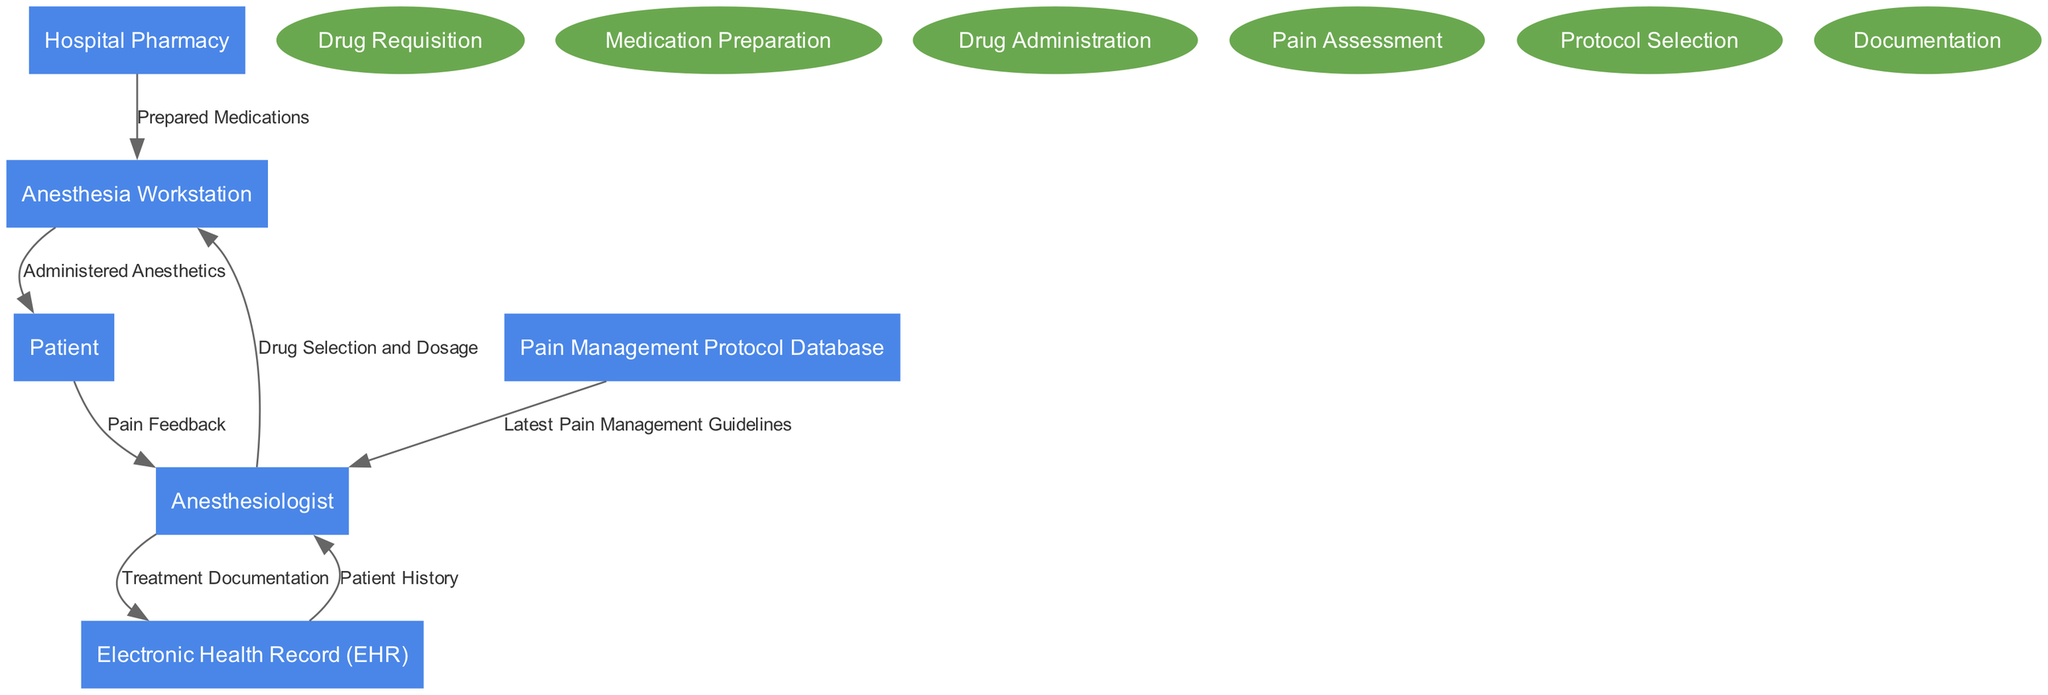What are the entities in the diagram? The entities in the diagram are the distinct components that interact within the anesthetic drug administration process. They can be identified as separate nodes in the diagram. In this case, the entities are: Hospital Pharmacy, Anesthesia Workstation, Patient, Electronic Health Record (EHR), Anesthesiologist, and Pain Management Protocol Database.
Answer: Hospital Pharmacy, Anesthesia Workstation, Patient, Electronic Health Record (EHR), Anesthesiologist, Pain Management Protocol Database How many processes are represented in the diagram? The processes are the actions or series of tasks carried out in the anesthetic process, represented as elliptical nodes in the diagram. There are six listed processes: Drug Requisition, Medication Preparation, Drug Administration, Pain Assessment, Protocol Selection, and Documentation. By counting these, we can determine there are six processes in total.
Answer: 6 What type of data flow occurs between the Hospital Pharmacy and the Anesthesia Workstation? The data flow between the Hospital Pharmacy and the Anesthesia Workstation is labeled "Prepared Medications." This indicates the transfer of ready-to-use anesthetic medications from the pharmacy to the workstation, which is a critical step in the administration process.
Answer: Prepared Medications Which two nodes are connected by the flow labeled "Administered Anesthetics"? The flow labeled "Administered Anesthetics" connects the Anesthesia Workstation to the Patient. This data flow signifies that the medications prepared at the workstation are actually given to the patient, marking a key point in the process where treatment is delivered.
Answer: Anesthesia Workstation and Patient What role does the Anesthesiologist play regarding the Pain Management Protocol Database? The Anesthesiologist interacts with the Pain Management Protocol Database by receiving the "Latest Pain Management Guidelines." This entails that the anesthesiologist uses this database to assist in deciding best practices and treatment options during the anesthetic procedure, providing a foundation for effective pain management.
Answer: Latest Pain Management Guidelines What information does the Patient provide back to the Anesthesiologist? The Patient provides "Pain Feedback" to the Anesthesiologist. This feedback is crucial for adjusting pain management strategies and ensuring that the patient is comfortable throughout the procedure. It allows the anesthesiologist to assess the effectiveness of the administered anesthetics.
Answer: Pain Feedback What happens after the Anesthesiologist documents the treatment in the EHR? The action of documenting treatment in the Electronic Health Record (EHR) doesn't explicitly show a subsequent flow in the diagram. However, it implies that the patient's records are updated with the information regarding treatment, which is vital for future reference and continuity of care. It is an important endpoint in this process flow.
Answer: Documentation in EHR How many data flows are depicted in the diagram? A data flow represents the movement of information or materials between nodes in the diagram. By counting each connection_with its respective labels, we find there are a total of seven data flows illustrated in the diagram.
Answer: 7 What processes are facilitated by the Anesthesiologist? The processes facilitated by the Anesthesiologist are Drug Selection and Dosage, Pain Assessment, and Treatment Documentation. These tasks involve making clinical decisions about drug administration and monitoring pain, thereby playing a central role in the anesthetic administration process.
Answer: Drug Selection and Dosage, Pain Assessment, Treatment Documentation 